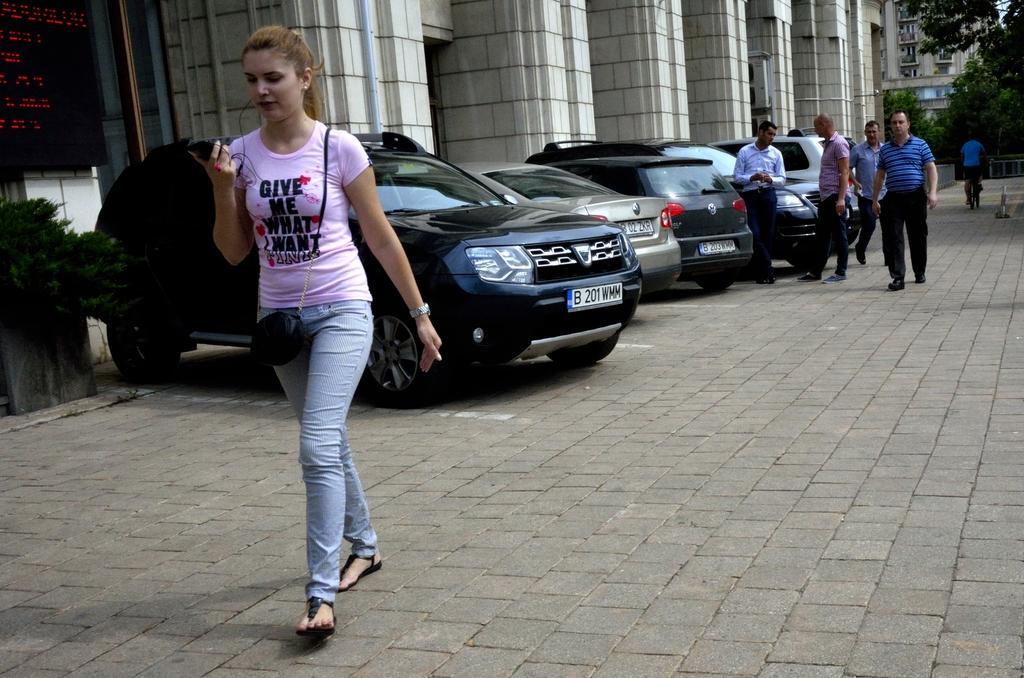Could you give a brief overview of what you see in this image? In this image I can see few vehicles and I can see few people are standing. I can also see few buildings, trees, a plant and here on these cars I can see something is written. I can also see she is holding an object and I can see she is carrying a bag. 